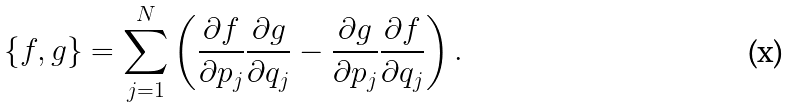Convert formula to latex. <formula><loc_0><loc_0><loc_500><loc_500>\{ f , g \} = \sum _ { j = 1 } ^ { N } \left ( \frac { \partial f } { \partial p _ { j } } \frac { \partial g } { \partial q _ { j } } - \frac { \partial g } { \partial p _ { j } } \frac { \partial f } { \partial q _ { j } } \right ) .</formula> 